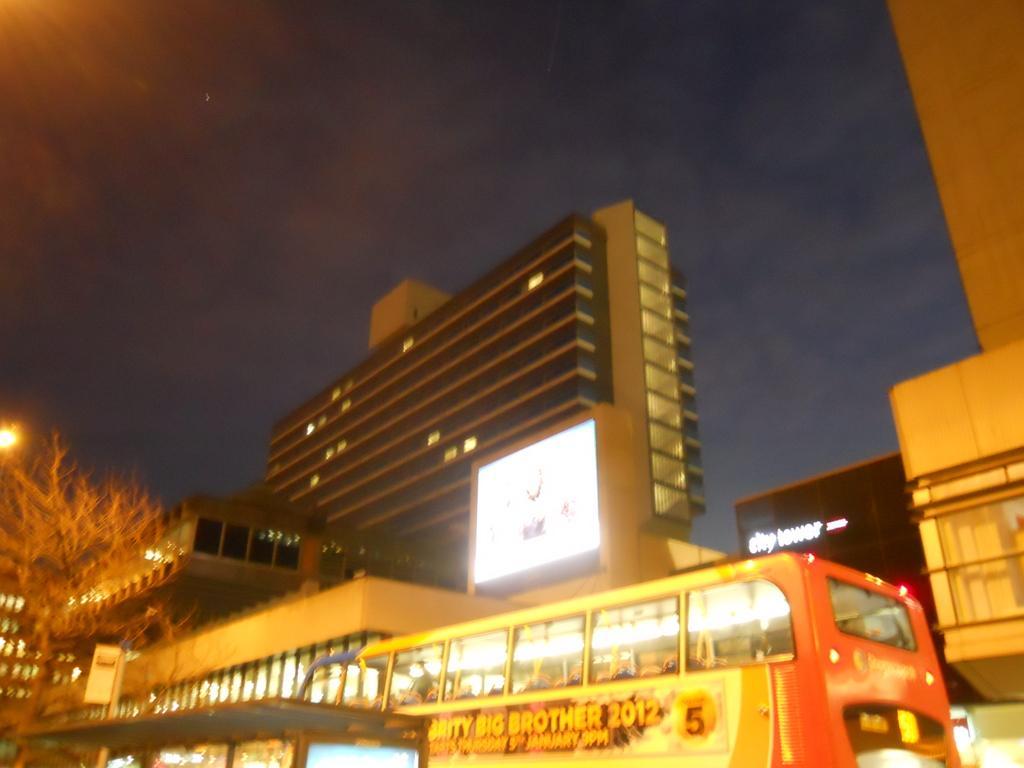Could you give a brief overview of what you see in this image? In this image there are few vehicles. Left bottom there is a tree. Background there are few buildings. Top of the image there is sky. 